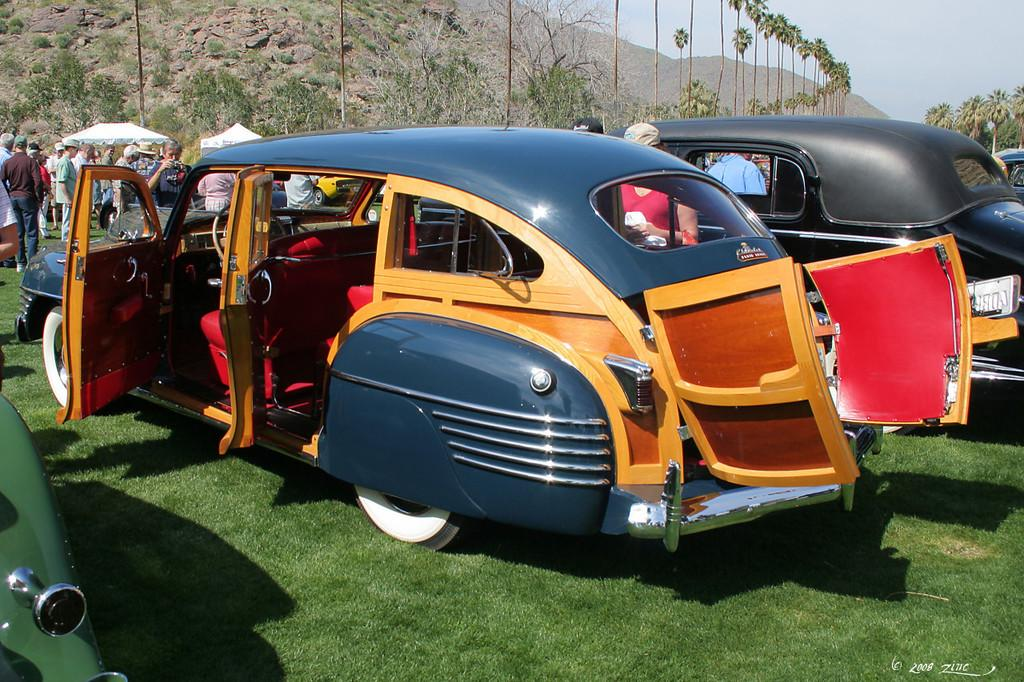What type of vegetation is present in the image? There is grass in the image. What else can be seen in the image besides grass? There are vehicles and people in the image. What can be seen in the background of the image? There are hills, trees, and the sky visible in the background of the image. Can you tell me which expert is giving a lecture in the image? There is no expert giving a lecture in the image; it features grass, vehicles, people, hills, trees, and the sky. How many bees can be seen buzzing around the trees in the image? There are no bees present in the image; it only features grass, vehicles, people, hills, trees, and the sky. 